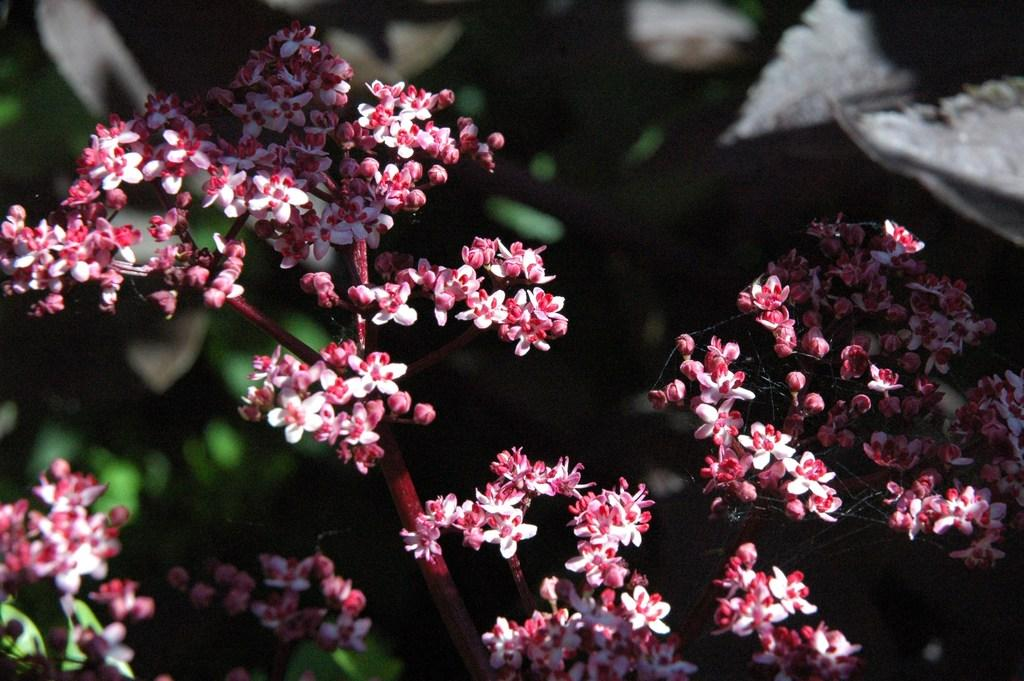What type of flora is present in the image? There are flowers in the image. Can you describe the colors of the flowers? The flowers are pink and white in color. What type of boat is visible in the image? There is no boat present in the image; it only features flowers. What material is the linen made of in the image? There is no linen present in the image; it only features flowers. 